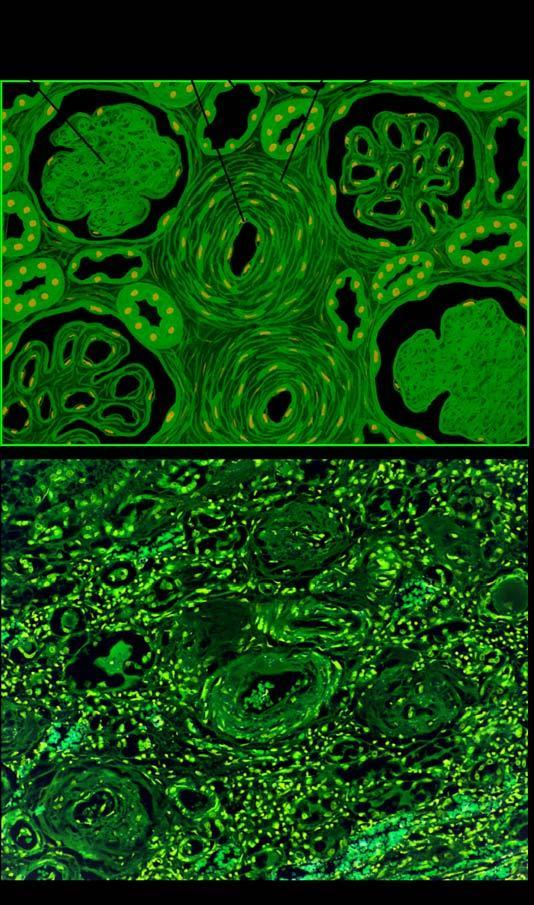what include sclerosed glomeruli, tubular atrophy and fine interstitial fibrosis?
Answer the question using a single word or phrase. Parenchymal changes 